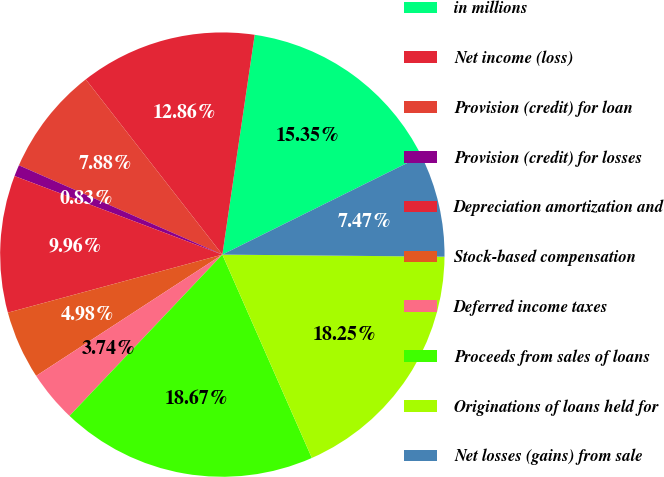Convert chart to OTSL. <chart><loc_0><loc_0><loc_500><loc_500><pie_chart><fcel>in millions<fcel>Net income (loss)<fcel>Provision (credit) for loan<fcel>Provision (credit) for losses<fcel>Depreciation amortization and<fcel>Stock-based compensation<fcel>Deferred income taxes<fcel>Proceeds from sales of loans<fcel>Originations of loans held for<fcel>Net losses (gains) from sale<nl><fcel>15.35%<fcel>12.86%<fcel>7.88%<fcel>0.83%<fcel>9.96%<fcel>4.98%<fcel>3.74%<fcel>18.67%<fcel>18.25%<fcel>7.47%<nl></chart> 